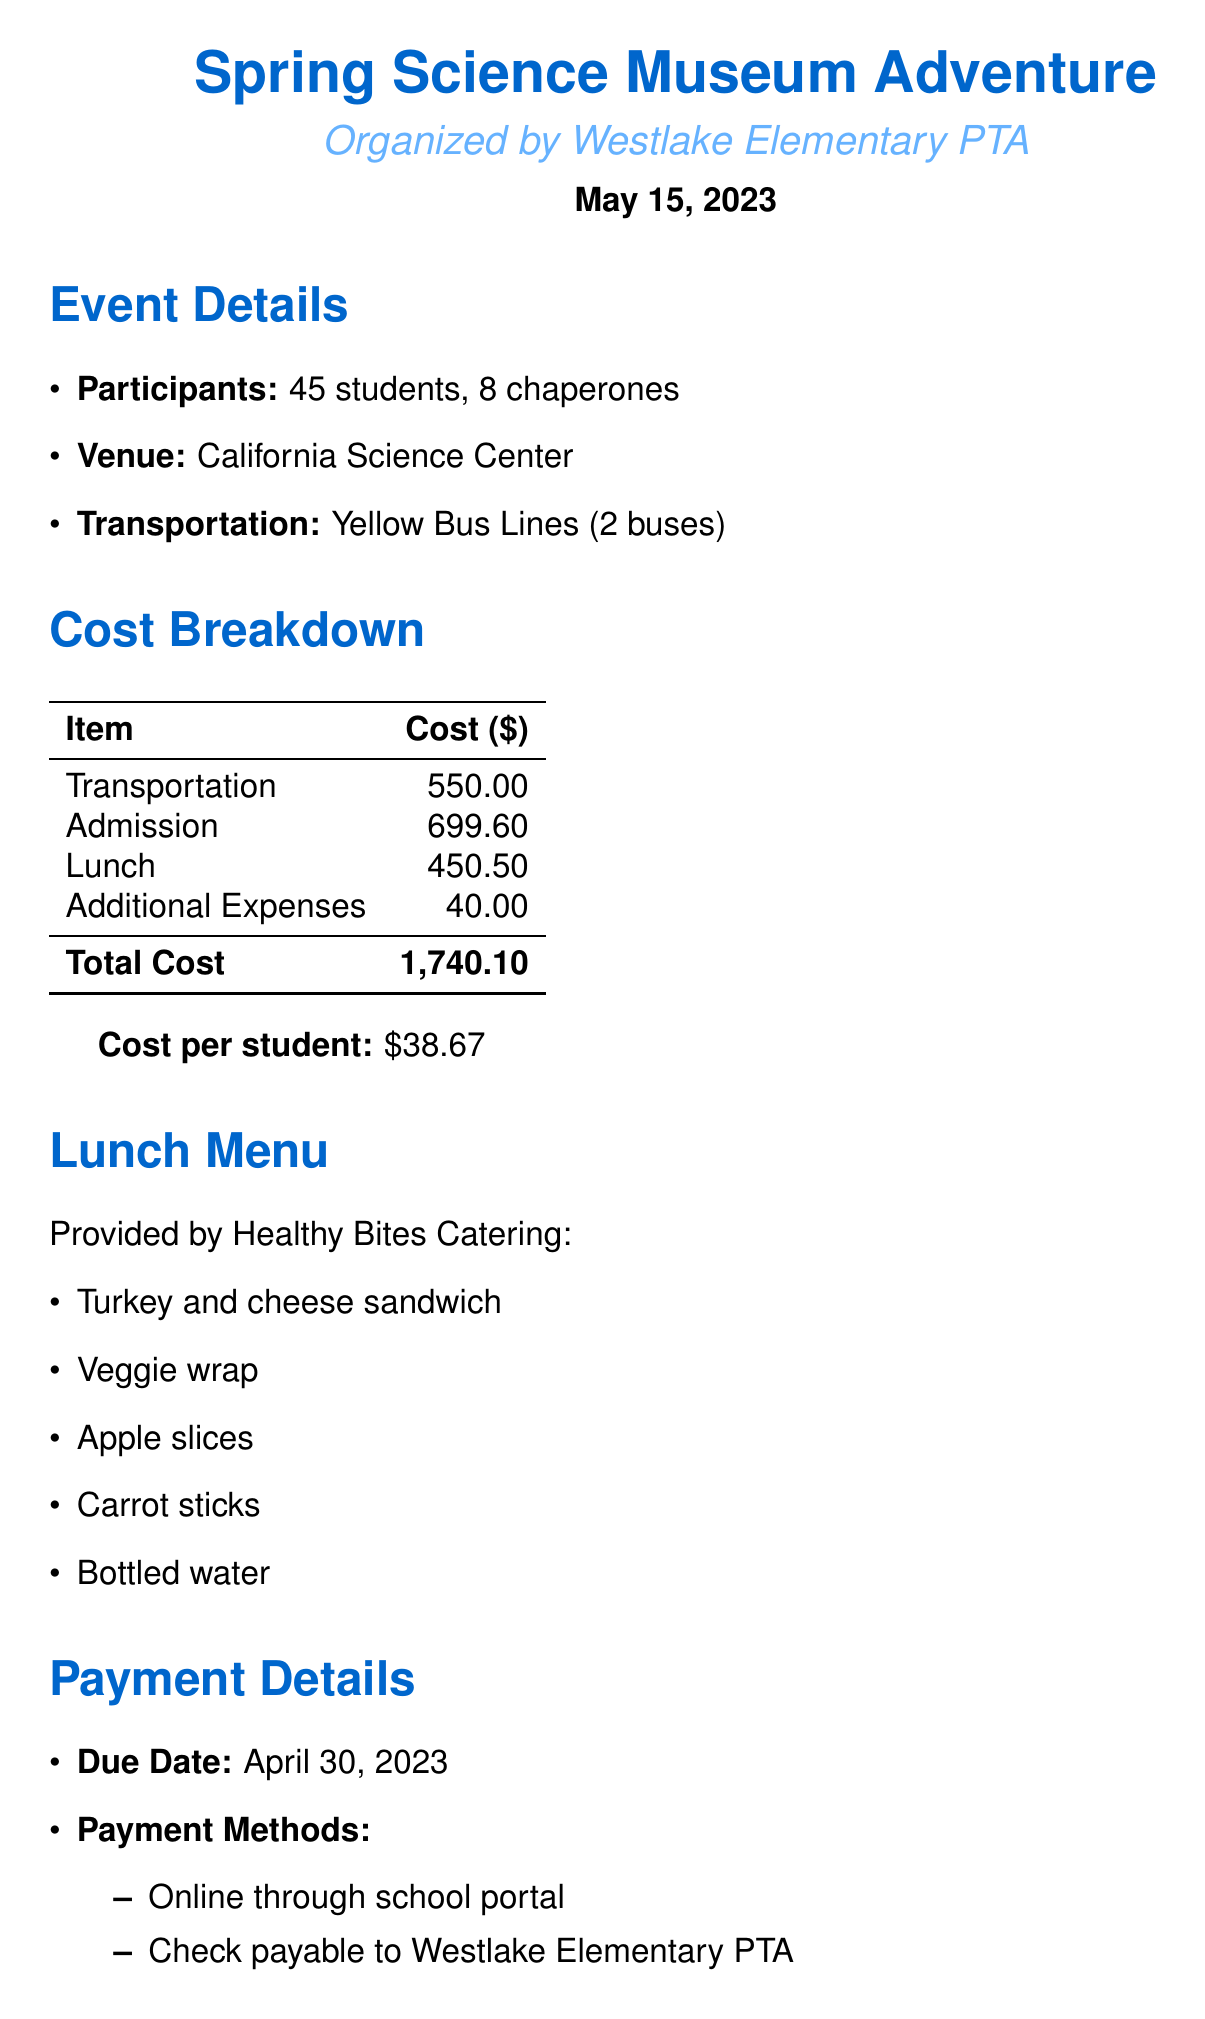What is the event name? The event name is located at the beginning of the document under the title section.
Answer: Spring Science Museum Adventure Who organized the event? The organizer is mentioned directly after the event name in the document.
Answer: Westlake Elementary PTA What is the total lunch cost? The total lunch cost appears in the cost breakdown table within the document.
Answer: 450.50 How many students are participating? The number of students is specified in the participants section.
Answer: 45 What is the cost per student? The cost per student is explicitly stated just below the total cost in the document.
Answer: 38.67 What is the due date for payment? The due date is listed under the payment details section.
Answer: April 30, 2023 What provider is responsible for lunch? The provider for lunch is detailed in the lunch section of the document.
Answer: Healthy Bites Catering How many chaperones are there? The number of chaperones can be found in the participants section as well.
Answer: 8 What items are included in the lunch menu? The lunch menu items are listed in the lunch section of the document.
Answer: Turkey and cheese sandwich, Veggie wrap, Apple slices, Carrot sticks, Bottled water 